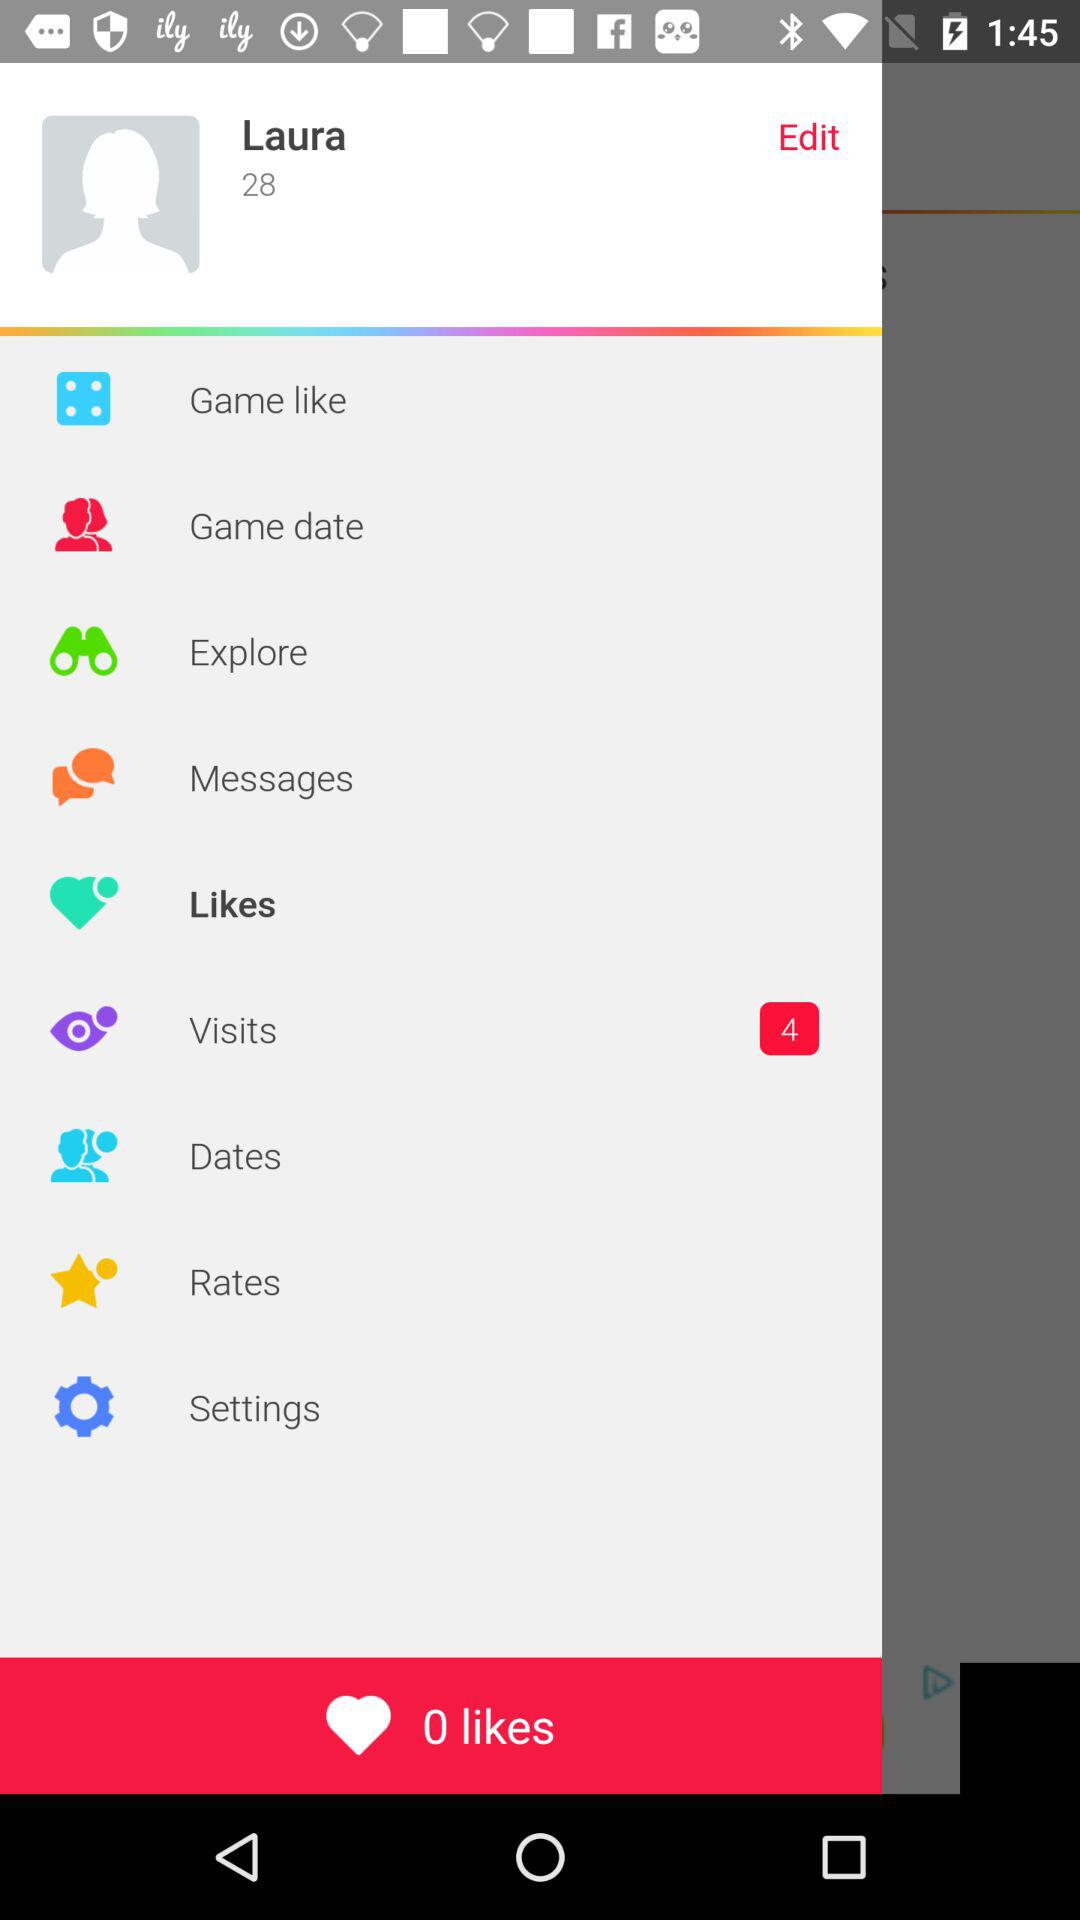What is the user name? The user name is Laura. 